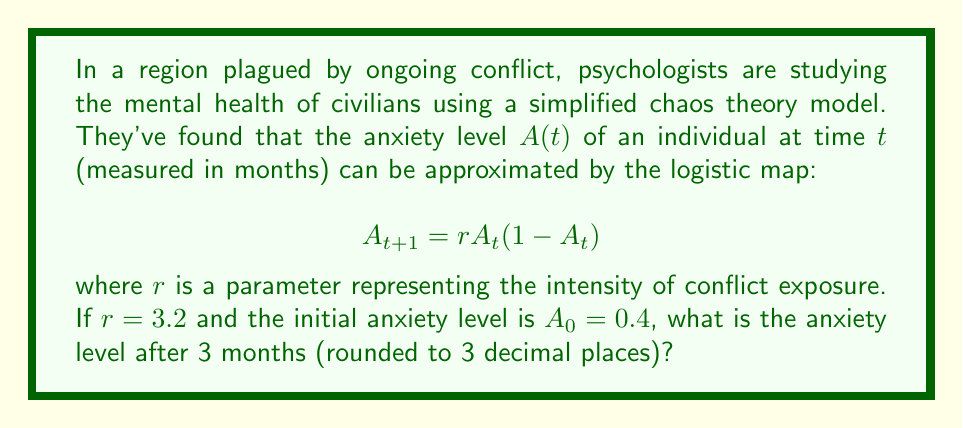Help me with this question. To solve this problem, we need to iterate the logistic map equation for 3 months:

1) First, let's calculate $A_1$:
   $$A_1 = 3.2 \cdot 0.4 \cdot (1-0.4) = 3.2 \cdot 0.4 \cdot 0.6 = 0.768$$

2) Now, we calculate $A_2$ using $A_1$:
   $$A_2 = 3.2 \cdot 0.768 \cdot (1-0.768) = 3.2 \cdot 0.768 \cdot 0.232 = 0.570163$$

3) Finally, we calculate $A_3$ using $A_2$:
   $$A_3 = 3.2 \cdot 0.570163 \cdot (1-0.570163) = 3.2 \cdot 0.570163 \cdot 0.429837 = 0.784972$$

4) Rounding to 3 decimal places:
   $A_3 \approx 0.785$

This result shows how the anxiety level fluctuates over time, demonstrating the unpredictable nature of psychological responses to prolonged conflict exposure, as modeled by chaos theory.
Answer: 0.785 